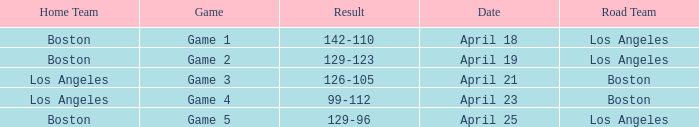WHAT IS THE HOME TEAM ON APRIL 25? Boston. 